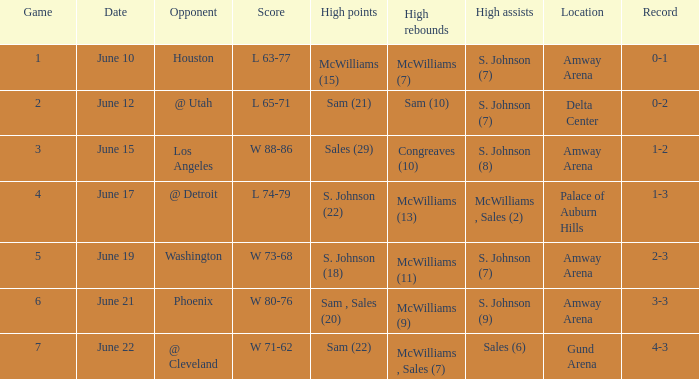Specify the total count of dates for l 63-7 1.0. Can you parse all the data within this table? {'header': ['Game', 'Date', 'Opponent', 'Score', 'High points', 'High rebounds', 'High assists', 'Location', 'Record'], 'rows': [['1', 'June 10', 'Houston', 'L 63-77', 'McWilliams (15)', 'McWilliams (7)', 'S. Johnson (7)', 'Amway Arena', '0-1'], ['2', 'June 12', '@ Utah', 'L 65-71', 'Sam (21)', 'Sam (10)', 'S. Johnson (7)', 'Delta Center', '0-2'], ['3', 'June 15', 'Los Angeles', 'W 88-86', 'Sales (29)', 'Congreaves (10)', 'S. Johnson (8)', 'Amway Arena', '1-2'], ['4', 'June 17', '@ Detroit', 'L 74-79', 'S. Johnson (22)', 'McWilliams (13)', 'McWilliams , Sales (2)', 'Palace of Auburn Hills', '1-3'], ['5', 'June 19', 'Washington', 'W 73-68', 'S. Johnson (18)', 'McWilliams (11)', 'S. Johnson (7)', 'Amway Arena', '2-3'], ['6', 'June 21', 'Phoenix', 'W 80-76', 'Sam , Sales (20)', 'McWilliams (9)', 'S. Johnson (9)', 'Amway Arena', '3-3'], ['7', 'June 22', '@ Cleveland', 'W 71-62', 'Sam (22)', 'McWilliams , Sales (7)', 'Sales (6)', 'Gund Arena', '4-3']]} 